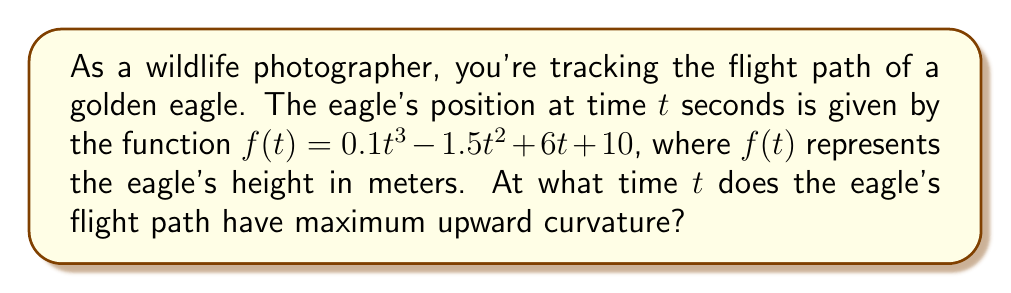What is the answer to this math problem? To find the time of maximum upward curvature, we need to analyze the second derivative of the flight path function.

Step 1: Find the first derivative of $f(t)$.
$$f'(t) = 0.3t^2 - 3t + 6$$

Step 2: Find the second derivative of $f(t)$.
$$f''(t) = 0.6t - 3$$

Step 3: The curvature is related to the magnitude of the second derivative. Maximum upward curvature occurs when $f''(t)$ is at its maximum positive value.

Step 4: Since $f''(t)$ is a linear function, its maximum value will occur at the largest possible $t$ value in the domain. However, we need to find where it transitions from negative to positive curvature.

Step 5: Set $f''(t) = 0$ and solve for $t$.
$$0.6t - 3 = 0$$
$$0.6t = 3$$
$$t = 5$$

Step 6: For $t < 5$, $f''(t) < 0$ (downward curvature), and for $t > 5$, $f''(t) > 0$ (upward curvature).

Therefore, the maximum upward curvature occurs just after $t = 5$ seconds.
Answer: $t = 5^+$ seconds 